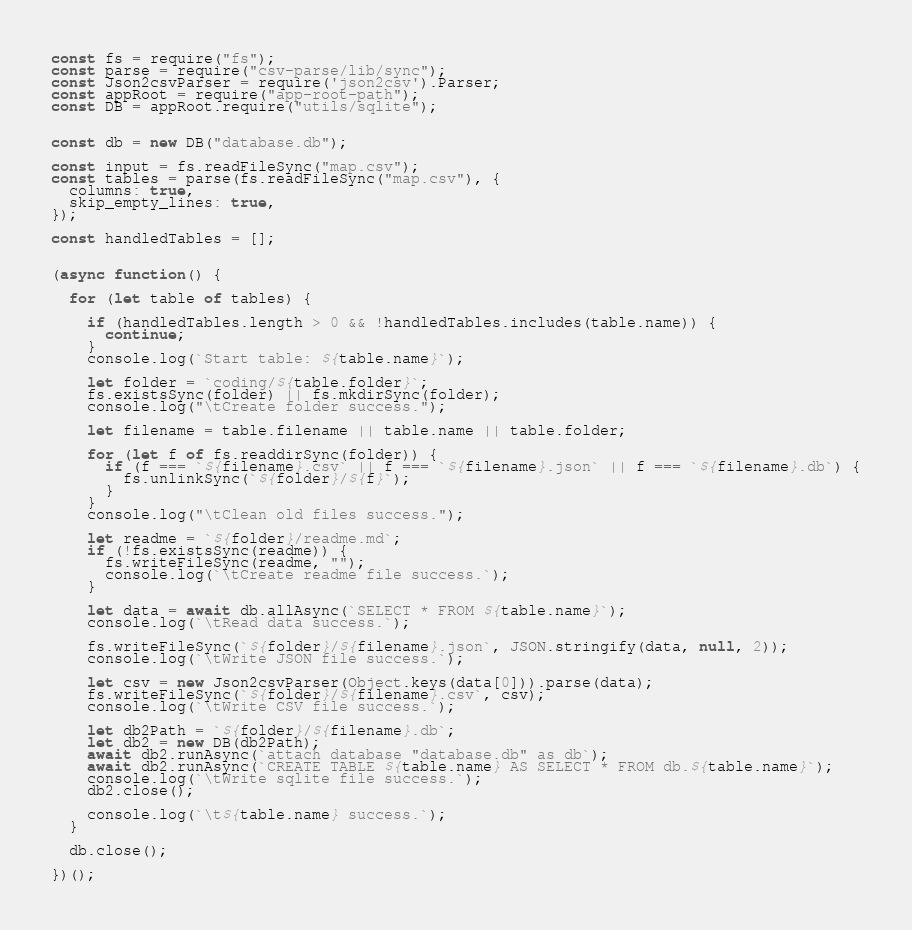Convert code to text. <code><loc_0><loc_0><loc_500><loc_500><_JavaScript_>
const fs = require("fs");
const parse = require("csv-parse/lib/sync");
const Json2csvParser = require('json2csv').Parser;
const appRoot = require("app-root-path");
const DB = appRoot.require("utils/sqlite");


const db = new DB("database.db");

const input = fs.readFileSync("map.csv");
const tables = parse(fs.readFileSync("map.csv"), {
  columns: true,
  skip_empty_lines: true,
});

const handledTables = [];


(async function() {

  for (let table of tables) {

    if (handledTables.length > 0 && !handledTables.includes(table.name)) {
      continue;
    }
    console.log(`Start table: ${table.name}`);

    let folder = `coding/${table.folder}`;
    fs.existsSync(folder) || fs.mkdirSync(folder);
    console.log("\tCreate folder success.");

    let filename = table.filename || table.name || table.folder;

    for (let f of fs.readdirSync(folder)) {
      if (f === `${filename}.csv` || f === `${filename}.json` || f === `${filename}.db`) {
        fs.unlinkSync(`${folder}/${f}`);
      }
    }
    console.log("\tClean old files success.");

    let readme = `${folder}/readme.md`;
    if (!fs.existsSync(readme)) {
      fs.writeFileSync(readme, "");
      console.log(`\tCreate readme file success.`);
    }

    let data = await db.allAsync(`SELECT * FROM ${table.name}`);
    console.log(`\tRead data success.`);

    fs.writeFileSync(`${folder}/${filename}.json`, JSON.stringify(data, null, 2));
    console.log(`\tWrite JSON file success.`);

    let csv = new Json2csvParser(Object.keys(data[0])).parse(data);
    fs.writeFileSync(`${folder}/${filename}.csv`, csv);
    console.log(`\tWrite CSV file success.`);

    let db2Path = `${folder}/${filename}.db`;
    let db2 = new DB(db2Path);
    await db2.runAsync(`attach database "database.db" as db`);
    await db2.runAsync(`CREATE TABLE ${table.name} AS SELECT * FROM db.${table.name}`);
    console.log(`\tWrite sqlite file success.`);
    db2.close();

    console.log(`\t${table.name} success.`);
  }

  db.close(); 

})();
</code> 